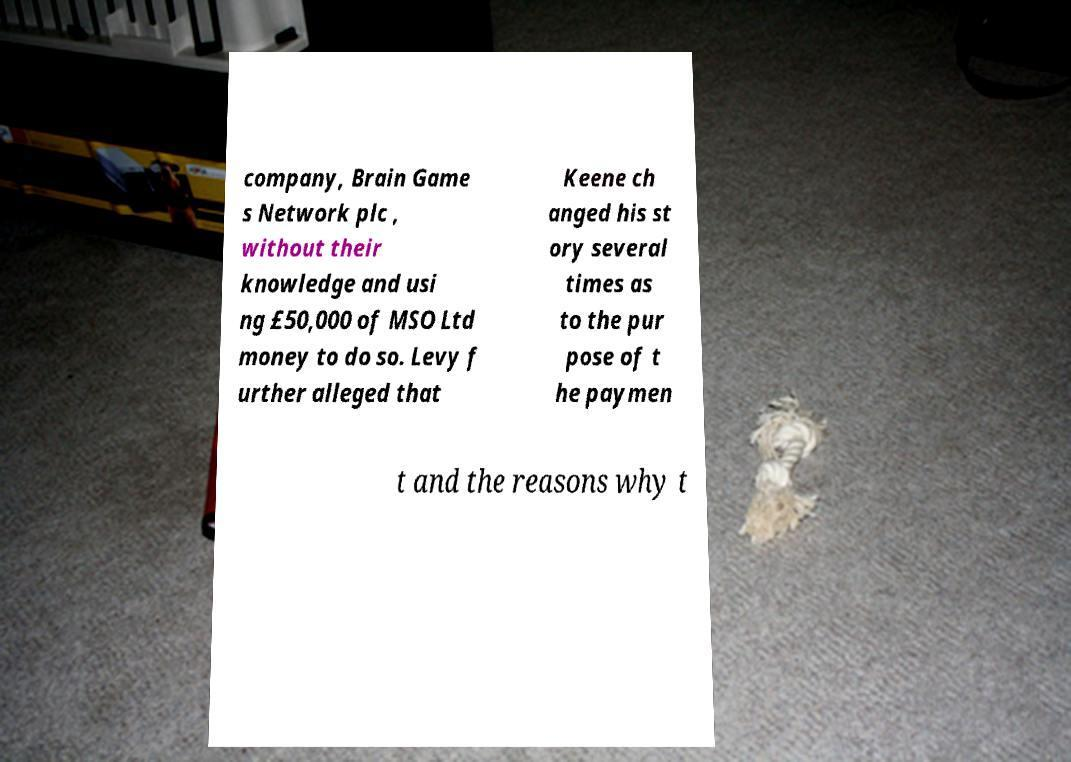I need the written content from this picture converted into text. Can you do that? company, Brain Game s Network plc , without their knowledge and usi ng £50,000 of MSO Ltd money to do so. Levy f urther alleged that Keene ch anged his st ory several times as to the pur pose of t he paymen t and the reasons why t 